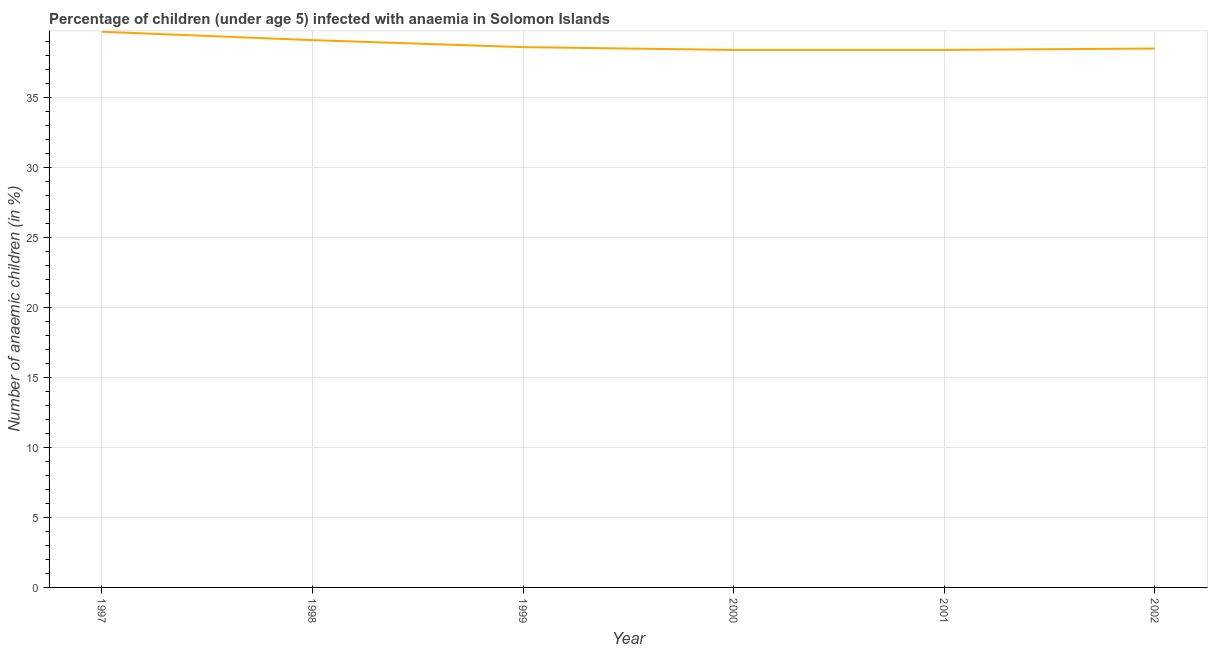What is the number of anaemic children in 1998?
Ensure brevity in your answer.  39.1. Across all years, what is the maximum number of anaemic children?
Offer a very short reply. 39.7. Across all years, what is the minimum number of anaemic children?
Make the answer very short. 38.4. In which year was the number of anaemic children minimum?
Provide a short and direct response. 2000. What is the sum of the number of anaemic children?
Your response must be concise. 232.7. What is the difference between the number of anaemic children in 1997 and 1998?
Ensure brevity in your answer.  0.6. What is the average number of anaemic children per year?
Offer a terse response. 38.78. What is the median number of anaemic children?
Offer a terse response. 38.55. What is the ratio of the number of anaemic children in 1997 to that in 2001?
Offer a very short reply. 1.03. Is the number of anaemic children in 1998 less than that in 2000?
Your response must be concise. No. What is the difference between the highest and the second highest number of anaemic children?
Offer a very short reply. 0.6. What is the difference between the highest and the lowest number of anaemic children?
Make the answer very short. 1.3. In how many years, is the number of anaemic children greater than the average number of anaemic children taken over all years?
Offer a very short reply. 2. How many years are there in the graph?
Keep it short and to the point. 6. Are the values on the major ticks of Y-axis written in scientific E-notation?
Your answer should be compact. No. Does the graph contain any zero values?
Provide a succinct answer. No. What is the title of the graph?
Your answer should be compact. Percentage of children (under age 5) infected with anaemia in Solomon Islands. What is the label or title of the X-axis?
Provide a short and direct response. Year. What is the label or title of the Y-axis?
Offer a terse response. Number of anaemic children (in %). What is the Number of anaemic children (in %) in 1997?
Keep it short and to the point. 39.7. What is the Number of anaemic children (in %) in 1998?
Give a very brief answer. 39.1. What is the Number of anaemic children (in %) of 1999?
Offer a very short reply. 38.6. What is the Number of anaemic children (in %) in 2000?
Give a very brief answer. 38.4. What is the Number of anaemic children (in %) in 2001?
Your answer should be compact. 38.4. What is the Number of anaemic children (in %) of 2002?
Provide a succinct answer. 38.5. What is the difference between the Number of anaemic children (in %) in 1997 and 1999?
Make the answer very short. 1.1. What is the difference between the Number of anaemic children (in %) in 1997 and 2001?
Your answer should be compact. 1.3. What is the difference between the Number of anaemic children (in %) in 1997 and 2002?
Ensure brevity in your answer.  1.2. What is the difference between the Number of anaemic children (in %) in 1998 and 1999?
Make the answer very short. 0.5. What is the difference between the Number of anaemic children (in %) in 1998 and 2000?
Offer a terse response. 0.7. What is the difference between the Number of anaemic children (in %) in 1998 and 2002?
Give a very brief answer. 0.6. What is the difference between the Number of anaemic children (in %) in 1999 and 2001?
Make the answer very short. 0.2. What is the difference between the Number of anaemic children (in %) in 1999 and 2002?
Offer a very short reply. 0.1. What is the difference between the Number of anaemic children (in %) in 2000 and 2001?
Ensure brevity in your answer.  0. What is the difference between the Number of anaemic children (in %) in 2001 and 2002?
Your response must be concise. -0.1. What is the ratio of the Number of anaemic children (in %) in 1997 to that in 1998?
Your answer should be compact. 1.01. What is the ratio of the Number of anaemic children (in %) in 1997 to that in 1999?
Offer a very short reply. 1.03. What is the ratio of the Number of anaemic children (in %) in 1997 to that in 2000?
Make the answer very short. 1.03. What is the ratio of the Number of anaemic children (in %) in 1997 to that in 2001?
Keep it short and to the point. 1.03. What is the ratio of the Number of anaemic children (in %) in 1997 to that in 2002?
Your answer should be compact. 1.03. What is the ratio of the Number of anaemic children (in %) in 1998 to that in 2000?
Your answer should be compact. 1.02. What is the ratio of the Number of anaemic children (in %) in 2000 to that in 2001?
Keep it short and to the point. 1. 